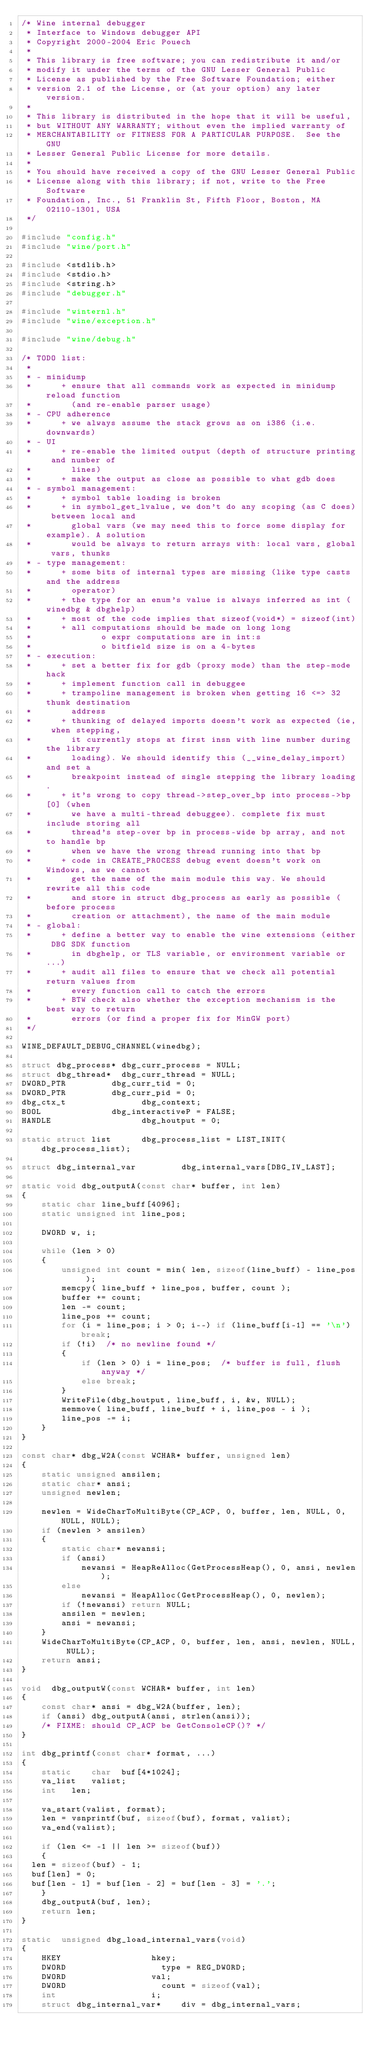<code> <loc_0><loc_0><loc_500><loc_500><_C_>/* Wine internal debugger
 * Interface to Windows debugger API
 * Copyright 2000-2004 Eric Pouech
 *
 * This library is free software; you can redistribute it and/or
 * modify it under the terms of the GNU Lesser General Public
 * License as published by the Free Software Foundation; either
 * version 2.1 of the License, or (at your option) any later version.
 *
 * This library is distributed in the hope that it will be useful,
 * but WITHOUT ANY WARRANTY; without even the implied warranty of
 * MERCHANTABILITY or FITNESS FOR A PARTICULAR PURPOSE.  See the GNU
 * Lesser General Public License for more details.
 *
 * You should have received a copy of the GNU Lesser General Public
 * License along with this library; if not, write to the Free Software
 * Foundation, Inc., 51 Franklin St, Fifth Floor, Boston, MA 02110-1301, USA
 */

#include "config.h"
#include "wine/port.h"

#include <stdlib.h>
#include <stdio.h>
#include <string.h>
#include "debugger.h"

#include "winternl.h"
#include "wine/exception.h"

#include "wine/debug.h"

/* TODO list:
 *
 * - minidump
 *      + ensure that all commands work as expected in minidump reload function
 *        (and re-enable parser usage)
 * - CPU adherence
 *      + we always assume the stack grows as on i386 (i.e. downwards)
 * - UI
 *      + re-enable the limited output (depth of structure printing and number of
 *        lines)
 *      + make the output as close as possible to what gdb does
 * - symbol management:
 *      + symbol table loading is broken
 *      + in symbol_get_lvalue, we don't do any scoping (as C does) between local and
 *        global vars (we may need this to force some display for example). A solution
 *        would be always to return arrays with: local vars, global vars, thunks
 * - type management:
 *      + some bits of internal types are missing (like type casts and the address
 *        operator)
 *      + the type for an enum's value is always inferred as int (winedbg & dbghelp)
 *      + most of the code implies that sizeof(void*) = sizeof(int)
 *      + all computations should be made on long long
 *              o expr computations are in int:s
 *              o bitfield size is on a 4-bytes
 * - execution:
 *      + set a better fix for gdb (proxy mode) than the step-mode hack
 *      + implement function call in debuggee
 *      + trampoline management is broken when getting 16 <=> 32 thunk destination
 *        address
 *      + thunking of delayed imports doesn't work as expected (ie, when stepping,
 *        it currently stops at first insn with line number during the library 
 *        loading). We should identify this (__wine_delay_import) and set a
 *        breakpoint instead of single stepping the library loading.
 *      + it's wrong to copy thread->step_over_bp into process->bp[0] (when 
 *        we have a multi-thread debuggee). complete fix must include storing all
 *        thread's step-over bp in process-wide bp array, and not to handle bp
 *        when we have the wrong thread running into that bp
 *      + code in CREATE_PROCESS debug event doesn't work on Windows, as we cannot
 *        get the name of the main module this way. We should rewrite all this code
 *        and store in struct dbg_process as early as possible (before process
 *        creation or attachment), the name of the main module
 * - global:
 *      + define a better way to enable the wine extensions (either DBG SDK function
 *        in dbghelp, or TLS variable, or environment variable or ...)
 *      + audit all files to ensure that we check all potential return values from
 *        every function call to catch the errors
 *      + BTW check also whether the exception mechanism is the best way to return
 *        errors (or find a proper fix for MinGW port)
 */

WINE_DEFAULT_DEBUG_CHANNEL(winedbg);

struct dbg_process*	dbg_curr_process = NULL;
struct dbg_thread*	dbg_curr_thread = NULL;
DWORD_PTR	        dbg_curr_tid = 0;
DWORD_PTR	        dbg_curr_pid = 0;
dbg_ctx_t               dbg_context;
BOOL    	        dbg_interactiveP = FALSE;
HANDLE                  dbg_houtput = 0;

static struct list      dbg_process_list = LIST_INIT(dbg_process_list);

struct dbg_internal_var         dbg_internal_vars[DBG_IV_LAST];

static void dbg_outputA(const char* buffer, int len)
{
    static char line_buff[4096];
    static unsigned int line_pos;

    DWORD w, i;

    while (len > 0)
    {
        unsigned int count = min( len, sizeof(line_buff) - line_pos );
        memcpy( line_buff + line_pos, buffer, count );
        buffer += count;
        len -= count;
        line_pos += count;
        for (i = line_pos; i > 0; i--) if (line_buff[i-1] == '\n') break;
        if (!i)  /* no newline found */
        {
            if (len > 0) i = line_pos;  /* buffer is full, flush anyway */
            else break;
        }
        WriteFile(dbg_houtput, line_buff, i, &w, NULL);
        memmove( line_buff, line_buff + i, line_pos - i );
        line_pos -= i;
    }
}

const char* dbg_W2A(const WCHAR* buffer, unsigned len)
{
    static unsigned ansilen;
    static char* ansi;
    unsigned newlen;

    newlen = WideCharToMultiByte(CP_ACP, 0, buffer, len, NULL, 0, NULL, NULL);
    if (newlen > ansilen)
    {
        static char* newansi;
        if (ansi)
            newansi = HeapReAlloc(GetProcessHeap(), 0, ansi, newlen);
        else
            newansi = HeapAlloc(GetProcessHeap(), 0, newlen);
        if (!newansi) return NULL;
        ansilen = newlen;
        ansi = newansi;
    }
    WideCharToMultiByte(CP_ACP, 0, buffer, len, ansi, newlen, NULL, NULL);
    return ansi;
}

void	dbg_outputW(const WCHAR* buffer, int len)
{
    const char* ansi = dbg_W2A(buffer, len);
    if (ansi) dbg_outputA(ansi, strlen(ansi));
    /* FIXME: should CP_ACP be GetConsoleCP()? */
}

int	dbg_printf(const char* format, ...)
{
    static    char	buf[4*1024];
    va_list 	valist;
    int		len;

    va_start(valist, format);
    len = vsnprintf(buf, sizeof(buf), format, valist);
    va_end(valist);

    if (len <= -1 || len >= sizeof(buf)) 
    {
	len = sizeof(buf) - 1;
	buf[len] = 0;
	buf[len - 1] = buf[len - 2] = buf[len - 3] = '.';
    }
    dbg_outputA(buf, len);
    return len;
}

static	unsigned dbg_load_internal_vars(void)
{
    HKEY	                hkey;
    DWORD 	                type = REG_DWORD;
    DWORD	                val;
    DWORD 	                count = sizeof(val);
    int		                i;
    struct dbg_internal_var*    div = dbg_internal_vars;
</code> 